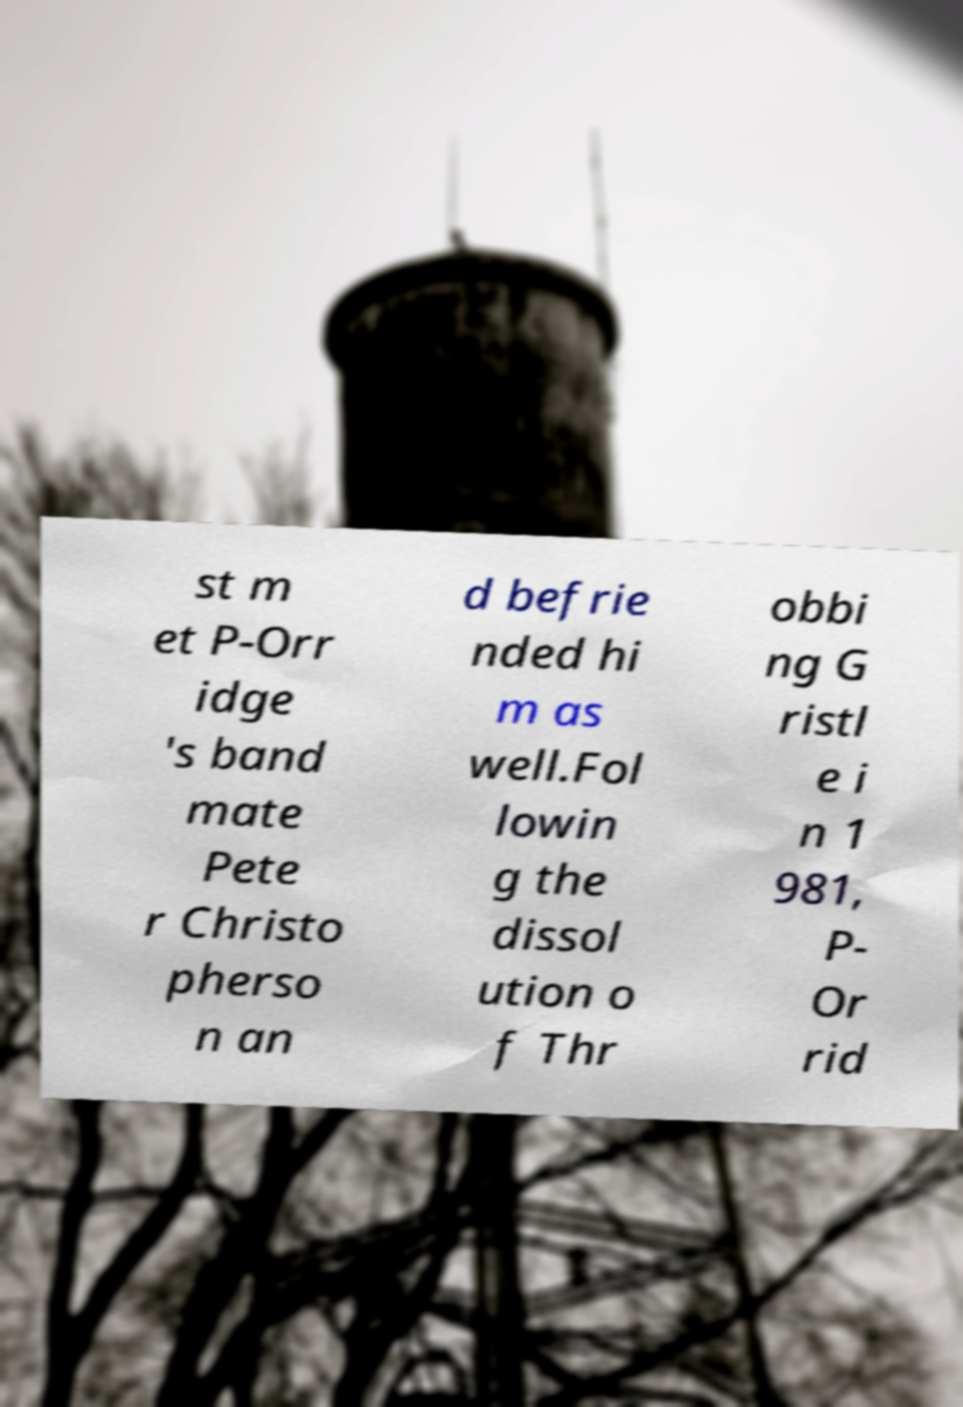Please identify and transcribe the text found in this image. st m et P-Orr idge 's band mate Pete r Christo pherso n an d befrie nded hi m as well.Fol lowin g the dissol ution o f Thr obbi ng G ristl e i n 1 981, P- Or rid 